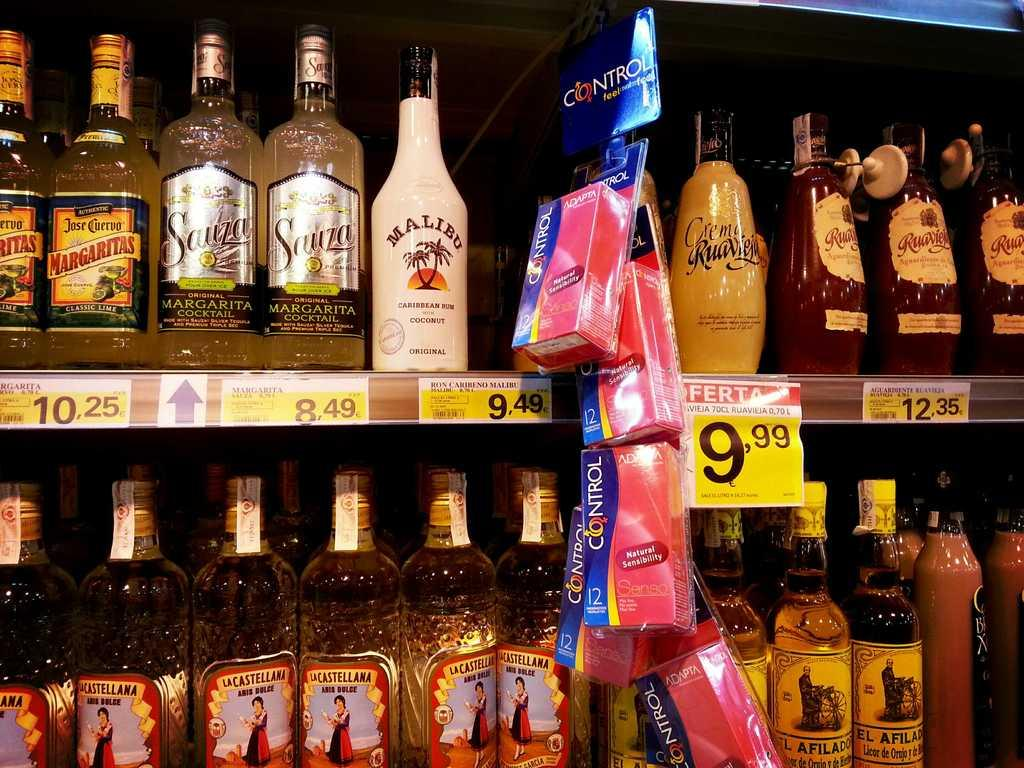<image>
Create a compact narrative representing the image presented. A display of alcoholic beverages including Malibu coconut rum. 